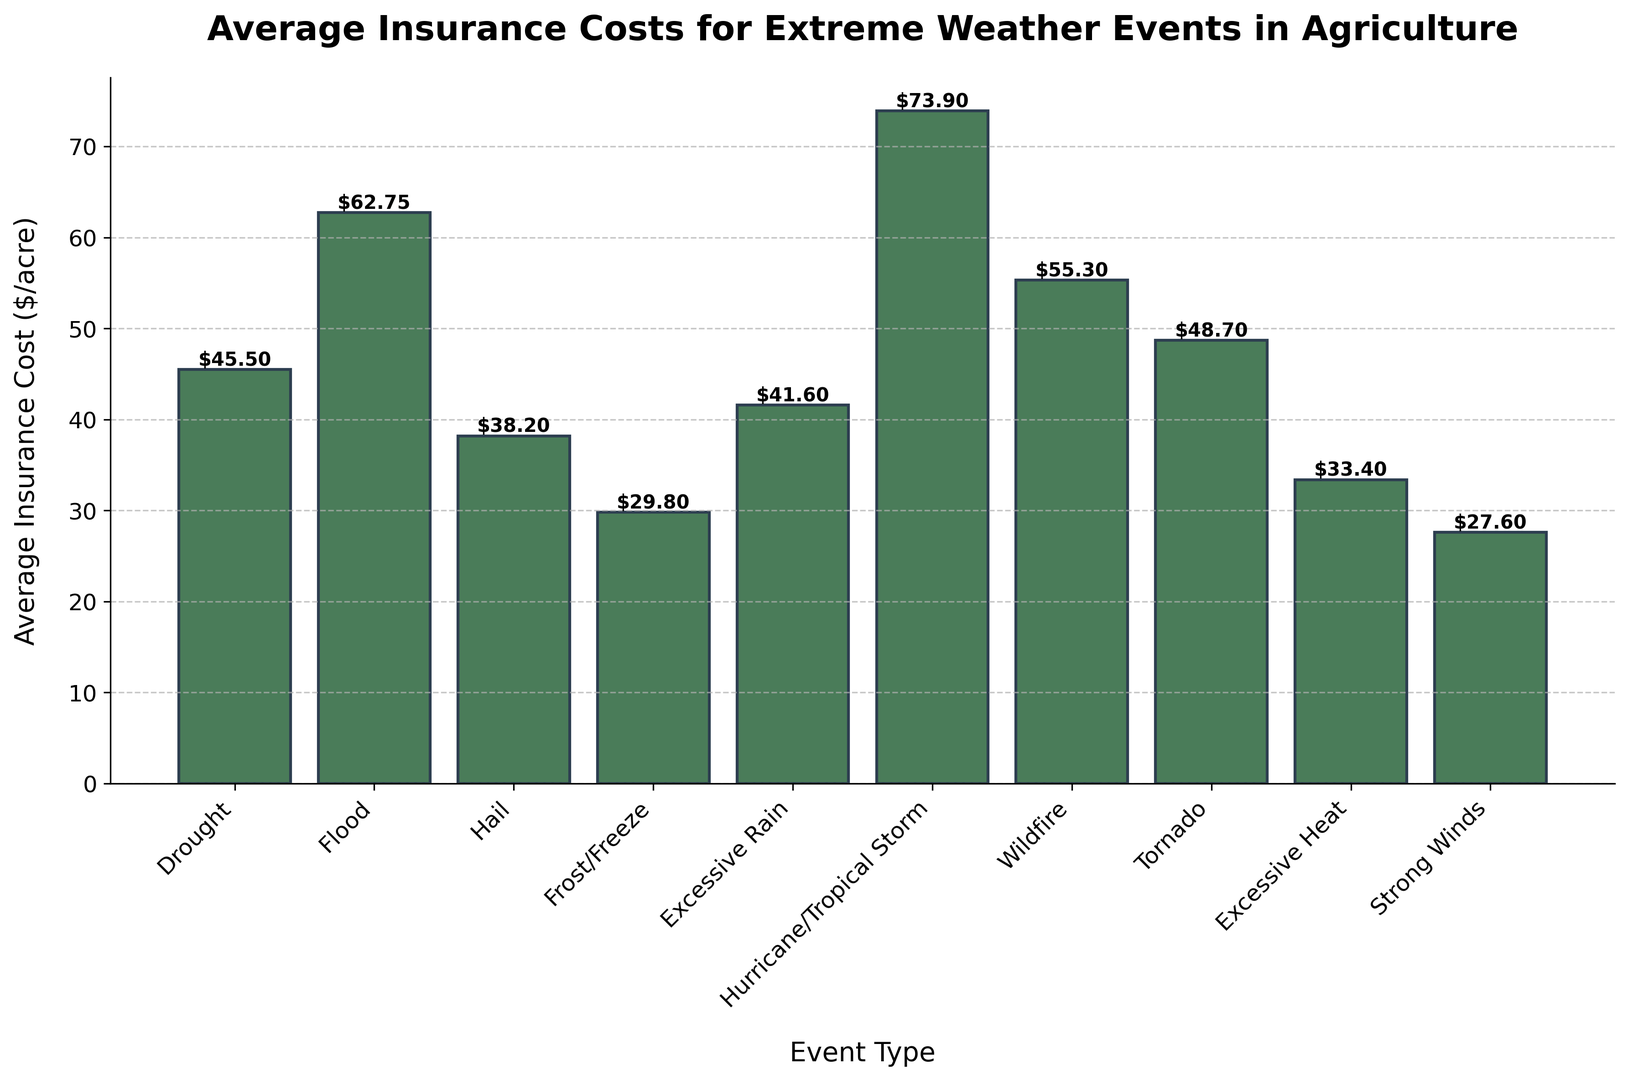Which extreme weather event has the highest average insurance cost? Look for the tallest bar in the chart, which represents the event with the highest insurance cost. The highest bar corresponds to Hurricane/Tropical Storm.
Answer: Hurricane/Tropical Storm How much more does it cost on average to insure against floods compared to droughts? Find the bars for Flood and Drought. The height of the Flood bar is $62.75 and the height of the Drought bar is $45.50. Subtract the Drought cost from the Flood cost: $62.75 - $45.50 = $17.25.
Answer: $17.25 Which event type has the lowest insurance cost, and what is its value? Look for the shortest bar in the chart, which represents the event with the lowest insurance cost. The shortest bar corresponds to Strong Winds, with a cost of $27.60.
Answer: Strong Winds, $27.60 By how much does the insurance cost of hail differ from excessive heat? Find the bars for Hail and Excessive Heat. The height of the Hail bar is $38.20 and the height of the Excessive Heat bar is $33.40. Subtract the Excessive Heat cost from the Hail cost: $38.20 - $33.40 = $4.80.
Answer: $4.80 What is the combined insurance cost for Wildfire and Tornado? Add the heights of the Wildfire and Tornado bars. The Wildfire cost is $55.30 and the Tornado cost is $48.70. Therefore, $55.30 + $48.70 = $104.00.
Answer: $104.00 Which events have an insurance cost greater than $50 per acre? Identify all bars that are taller than the $50 mark. These correspond to Flood, Hurricane/Tropical Storm, Wildfire, and Tornado.
Answer: Flood, Hurricane/Tropical Storm, Wildfire, Tornado How does the insurance cost of frost/freeze compare with excessive rain? Find the bars for Frost/Freeze and Excessive Rain. The Frost/Freeze cost is $29.80 and the Excessive Rain cost is $41.60. Frost/Freeze is cheaper than Excessive Rain by $41.60 - $29.80 = $11.80.
Answer: $11.80 less Arrange the events in descending order based on their insurance costs. Look at the heights of all bars and list them from tallest to shortest: Hurricane/Tropical Storm ($73.90), Flood ($62.75), Wildfire ($55.30), Tornado ($48.70), Drought ($45.50), Excessive Rain ($41.60), Hail ($38.20), Excessive Heat ($33.40), Frost/Freeze ($29.80), Strong Winds ($27.60).
Answer: Hurricane/Tropical Storm, Flood, Wildfire, Tornado, Drought, Excessive Rain, Hail, Excessive Heat, Frost/Freeze, Strong Winds 